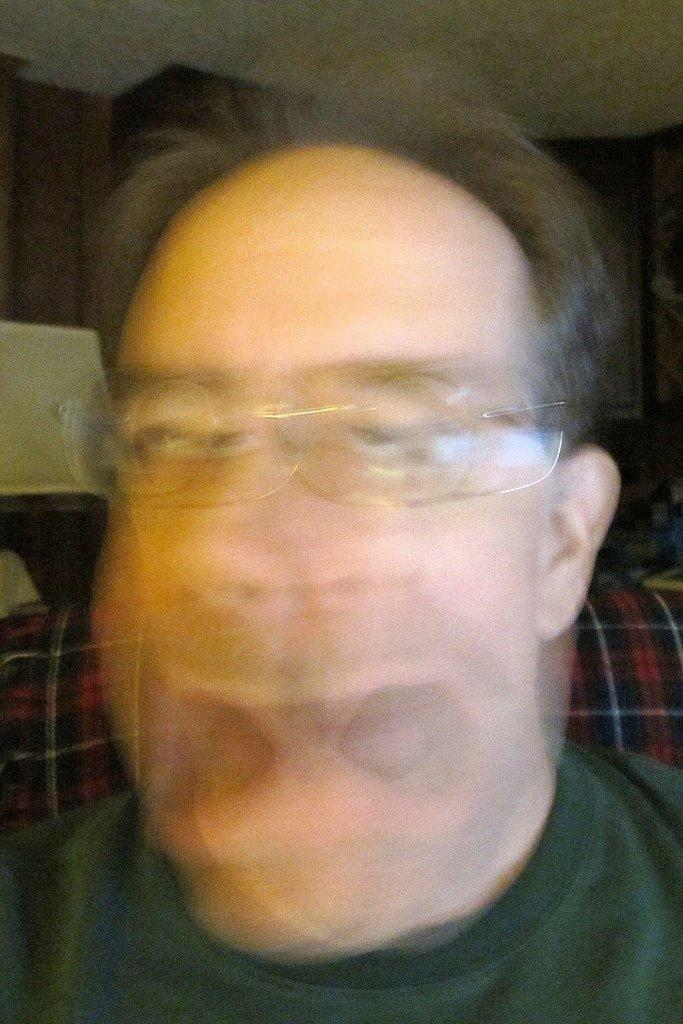What is present in the image? There is a man in the image. Can you describe the man's appearance? The man is wearing spectacles. What type of sofa is the man sitting on in the image? There is no sofa present in the image; it only features a man wearing spectacles. What kind of jelly can be seen in the image? There is no jelly present in the image. 